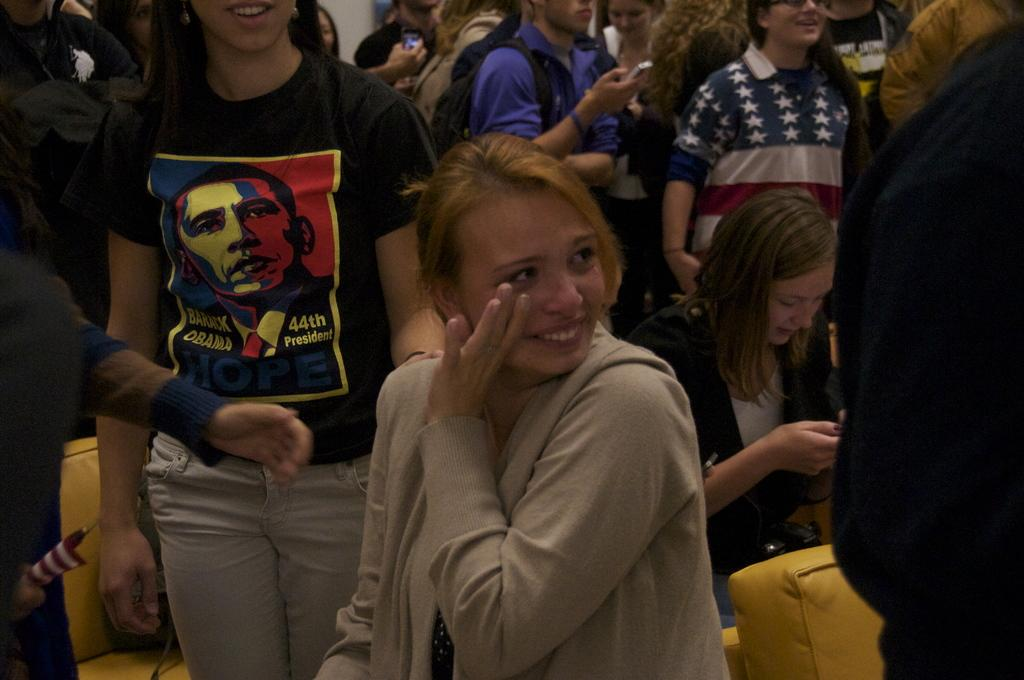Who is the main subject in the image? There is a woman in the center of the image. What is the woman doing in the image? The woman is smiling. Can you describe the people in the background of the image? Some people in the background are holding mobile phones. What objects are visible in the image that might be used for sitting? There are seats visible in the image. What letters are being processed by the woman in the image? There are no letters or any indication of a process being carried out by the woman in the image. Can you see a rose in the woman's hand in the image? There is no rose visible in the woman's hand or anywhere else in the image. 